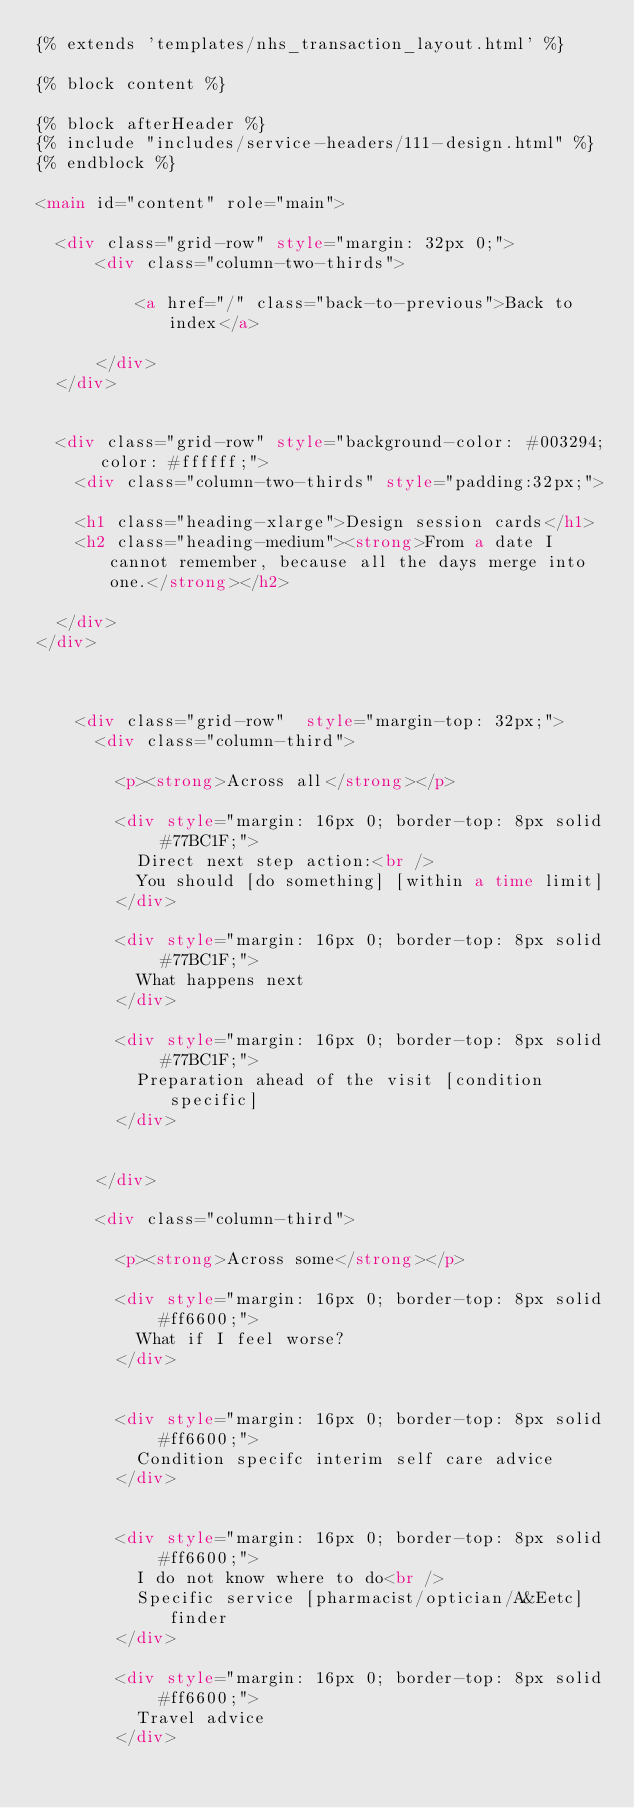<code> <loc_0><loc_0><loc_500><loc_500><_HTML_>{% extends 'templates/nhs_transaction_layout.html' %}

{% block content %}

{% block afterHeader %}
{% include "includes/service-headers/111-design.html" %}
{% endblock %}

<main id="content" role="main">

  <div class="grid-row" style="margin: 32px 0;">
      <div class="column-two-thirds">

          <a href="/" class="back-to-previous">Back to index</a>

      </div>
  </div>


  <div class="grid-row" style="background-color: #003294; color: #ffffff;">
    <div class="column-two-thirds" style="padding:32px;">

    <h1 class="heading-xlarge">Design session cards</h1>
    <h2 class="heading-medium"><strong>From a date I cannot remember, because all the days merge into one.</strong></h2>

  </div>
</div>



    <div class="grid-row"  style="margin-top: 32px;">
      <div class="column-third">

        <p><strong>Across all</strong></p>

        <div style="margin: 16px 0; border-top: 8px solid #77BC1F;">
          Direct next step action:<br />
          You should [do something] [within a time limit]
        </div>

        <div style="margin: 16px 0; border-top: 8px solid #77BC1F;">
          What happens next
        </div>

        <div style="margin: 16px 0; border-top: 8px solid #77BC1F;">
          Preparation ahead of the visit [condition specific]
        </div>


      </div>

      <div class="column-third">

        <p><strong>Across some</strong></p>

        <div style="margin: 16px 0; border-top: 8px solid #ff6600;">
          What if I feel worse?
        </div>


        <div style="margin: 16px 0; border-top: 8px solid #ff6600;">
          Condition specifc interim self care advice
        </div>


        <div style="margin: 16px 0; border-top: 8px solid #ff6600;">
          I do not know where to do<br />
          Specific service [pharmacist/optician/A&Eetc] finder
        </div>

        <div style="margin: 16px 0; border-top: 8px solid #ff6600;">
          Travel advice
        </div>
</code> 